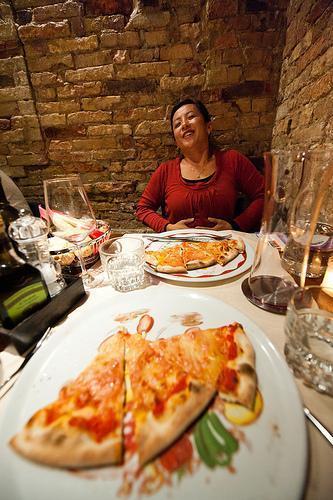How many women are there?
Give a very brief answer. 1. 